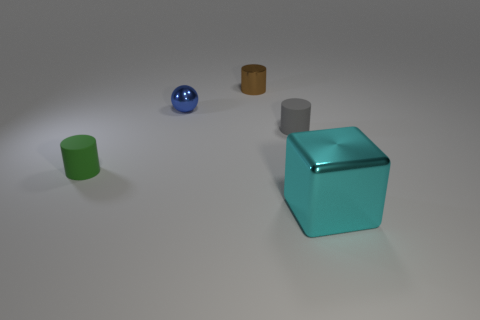Add 3 small things. How many objects exist? 8 Subtract 1 cylinders. How many cylinders are left? 2 Subtract all matte cylinders. How many cylinders are left? 1 Subtract all gray cylinders. How many red balls are left? 0 Subtract all tiny green cubes. Subtract all metallic things. How many objects are left? 2 Add 1 tiny matte objects. How many tiny matte objects are left? 3 Add 3 purple matte cylinders. How many purple matte cylinders exist? 3 Subtract 0 blue cubes. How many objects are left? 5 Subtract all cubes. How many objects are left? 4 Subtract all brown spheres. Subtract all blue cylinders. How many spheres are left? 1 